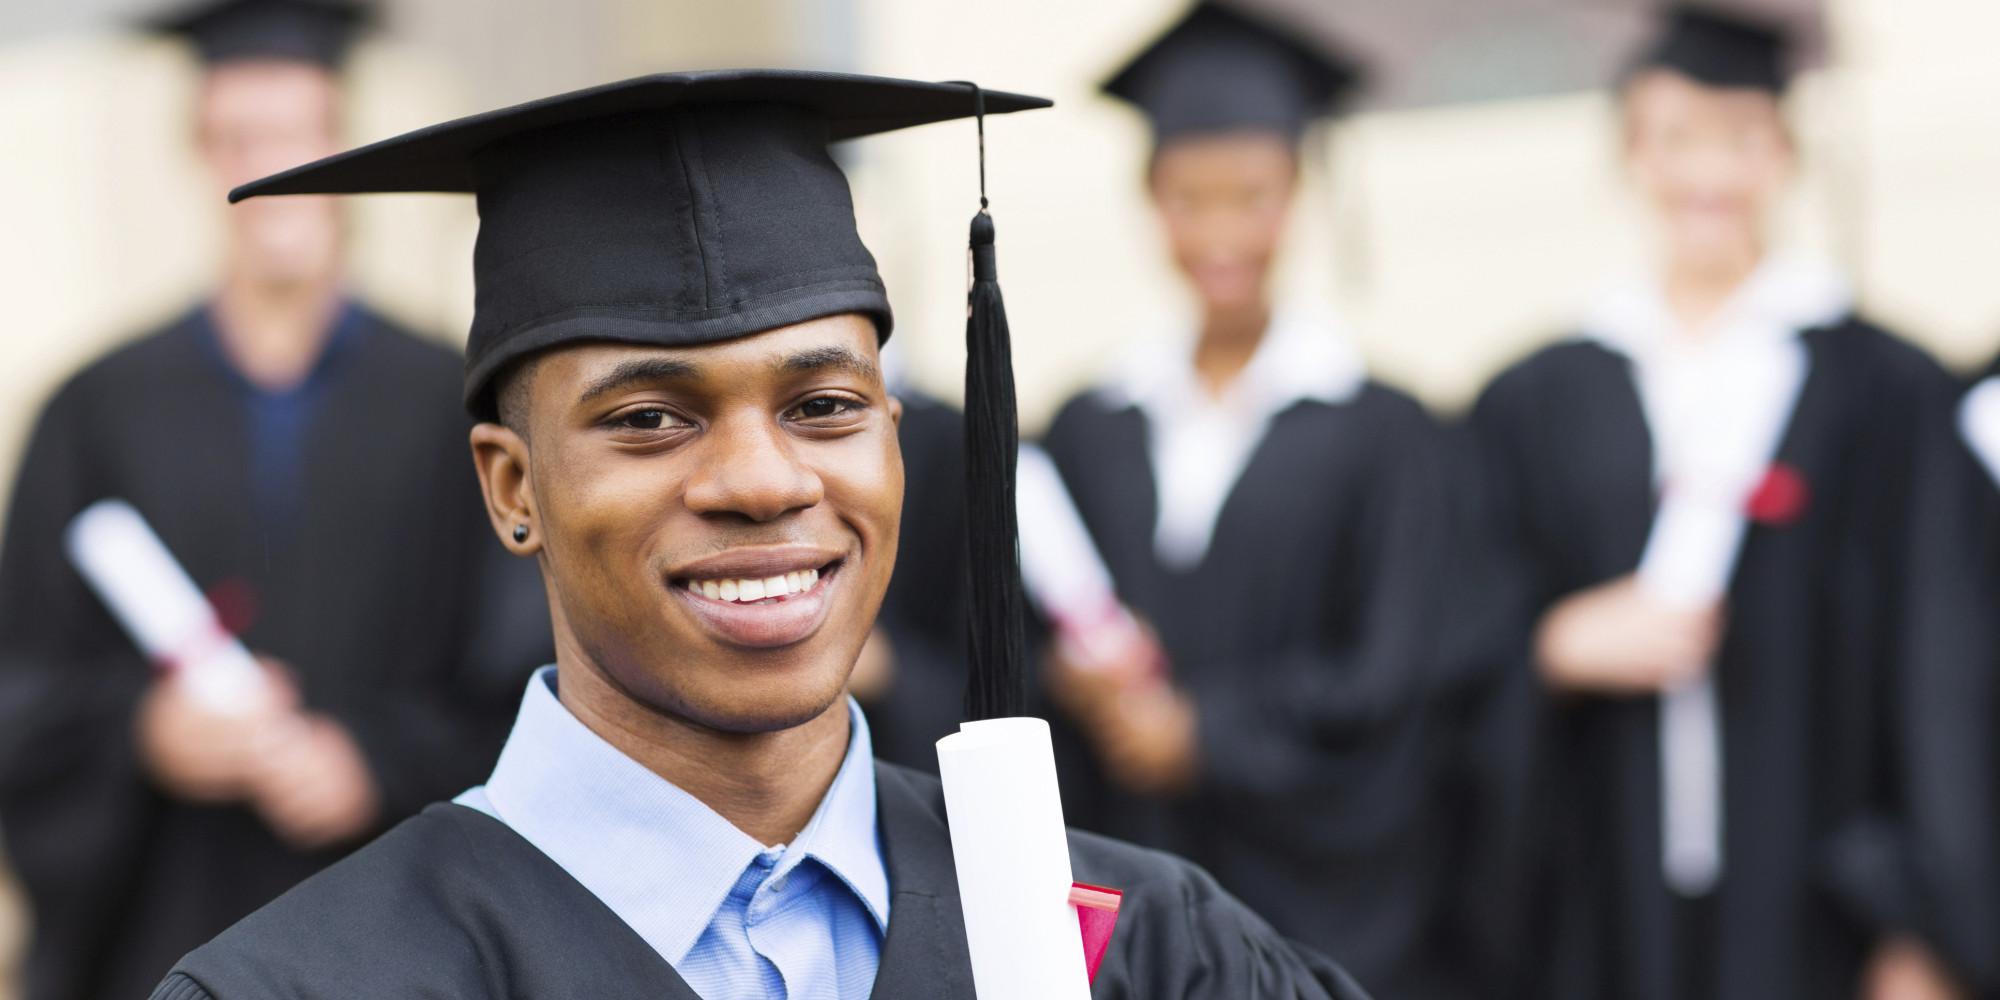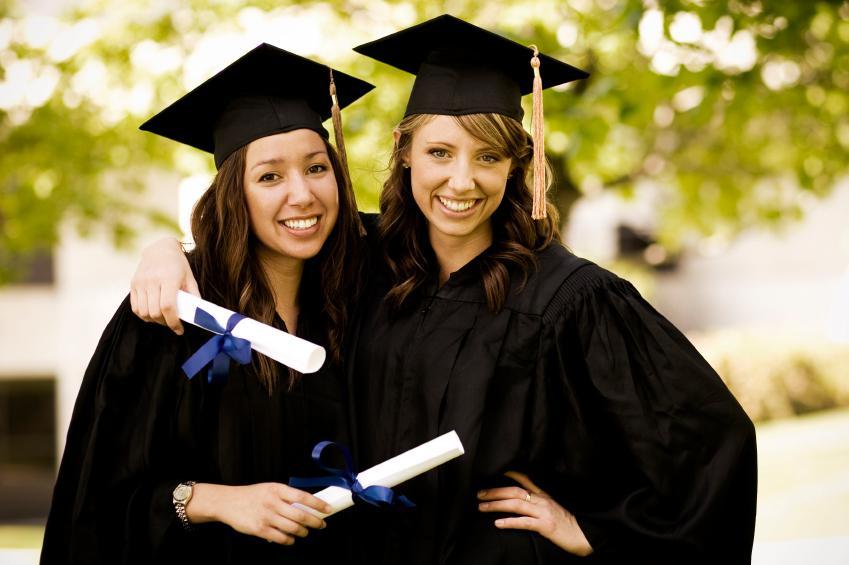The first image is the image on the left, the second image is the image on the right. Given the left and right images, does the statement "All graduates wear dark caps and robes, and the left image shows a smiling black graduate alone in the foreground." hold true? Answer yes or no. Yes. 